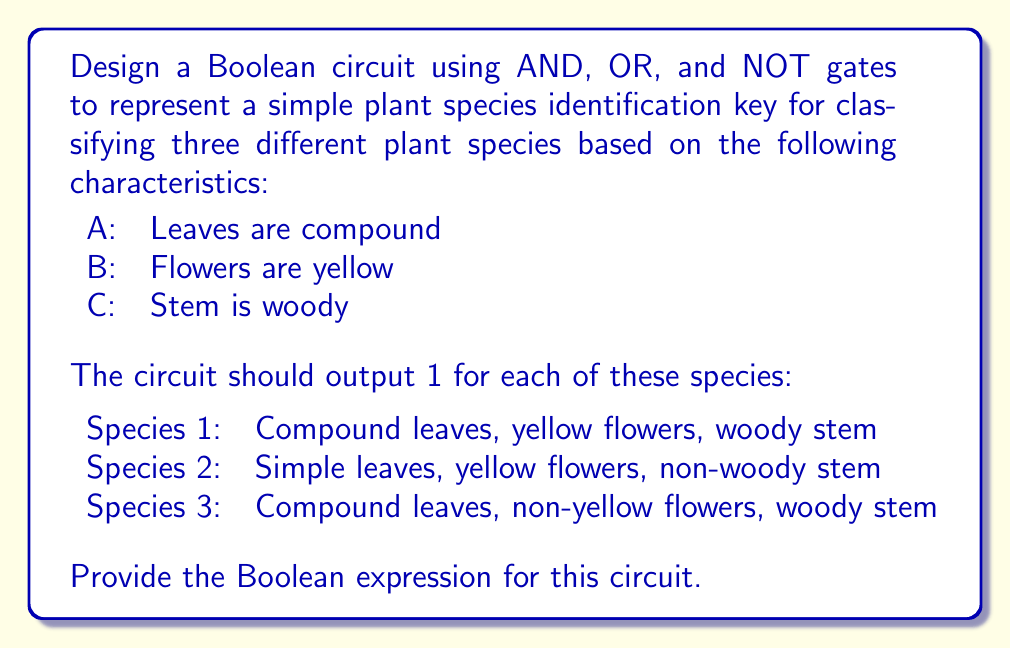Provide a solution to this math problem. Let's approach this step-by-step:

1) First, let's define our inputs:
   A: Leaves are compound (1 if true, 0 if false)
   B: Flowers are yellow (1 if true, 0 if false)
   C: Stem is woody (1 if true, 0 if false)

2) Now, let's create Boolean expressions for each species:

   Species 1: A AND B AND C
   Species 2: (NOT A) AND B AND (NOT C)
   Species 3: A AND (NOT B) AND C

3) We want the circuit to output 1 if any of these species are identified. This means we need to OR these expressions together.

4) The resulting Boolean expression is:

   $$(A \cdot B \cdot C) + (\overline{A} \cdot B \cdot \overline{C}) + (A \cdot \overline{B} \cdot C)$$

   Where:
   $\cdot$ represents AND
   $+$ represents OR
   $\overline{X}$ represents NOT X

5) This expression can be implemented using AND, OR, and NOT gates as follows:
   - Three 3-input AND gates for each species
   - NOT gates for $\overline{A}$, $\overline{B}$, and $\overline{C}$
   - One 3-input OR gate to combine the outputs of the AND gates

6) The resulting circuit will output 1 if the input matches any of the three specified species, and 0 otherwise.
Answer: $$(A \cdot B \cdot C) + (\overline{A} \cdot B \cdot \overline{C}) + (A \cdot \overline{B} \cdot C)$$ 